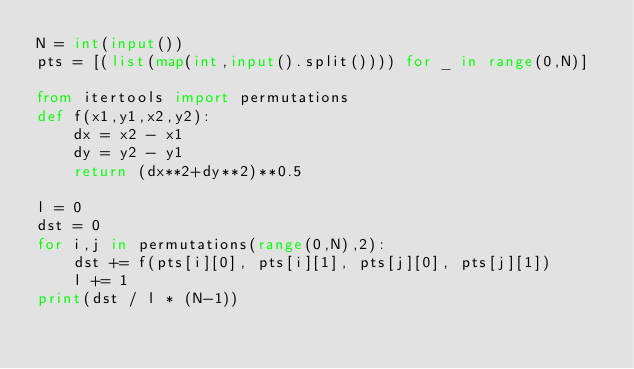<code> <loc_0><loc_0><loc_500><loc_500><_Python_>N = int(input())
pts = [(list(map(int,input().split()))) for _ in range(0,N)]

from itertools import permutations
def f(x1,y1,x2,y2):
    dx = x2 - x1
    dy = y2 - y1
    return (dx**2+dy**2)**0.5

l = 0
dst = 0
for i,j in permutations(range(0,N),2):
    dst += f(pts[i][0], pts[i][1], pts[j][0], pts[j][1])
    l += 1
print(dst / l * (N-1))</code> 